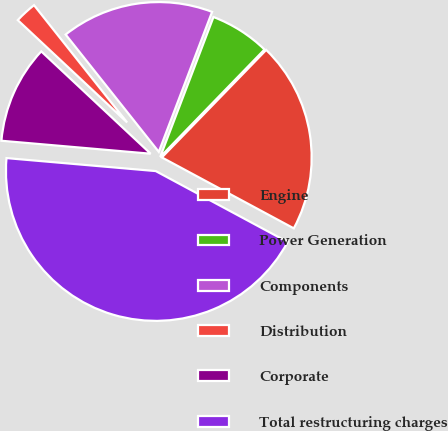Convert chart. <chart><loc_0><loc_0><loc_500><loc_500><pie_chart><fcel>Engine<fcel>Power Generation<fcel>Components<fcel>Distribution<fcel>Corporate<fcel>Total restructuring charges<nl><fcel>20.59%<fcel>6.47%<fcel>16.47%<fcel>2.35%<fcel>10.59%<fcel>43.53%<nl></chart> 